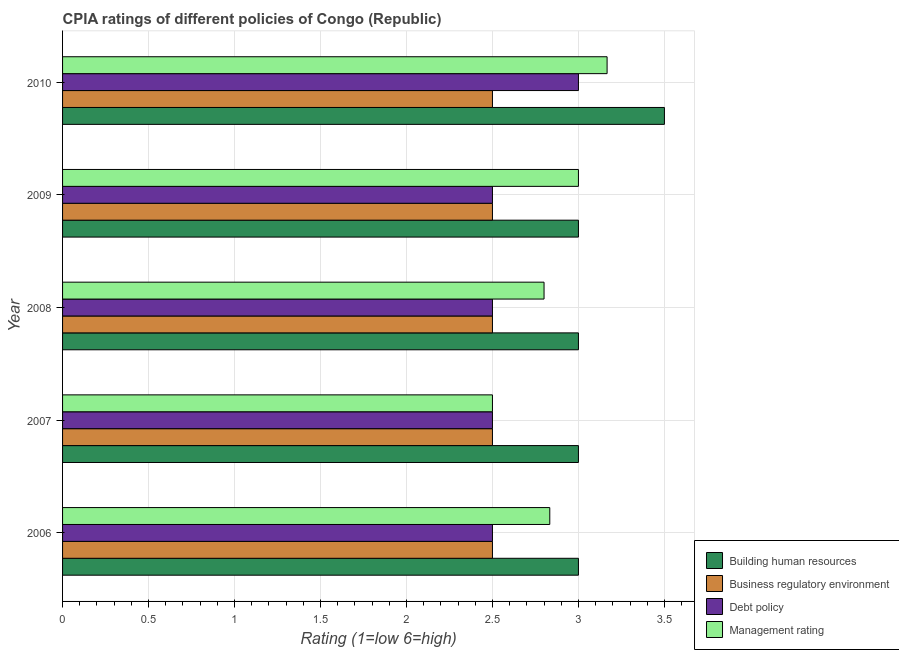How many different coloured bars are there?
Make the answer very short. 4. Are the number of bars per tick equal to the number of legend labels?
Offer a very short reply. Yes. How many bars are there on the 5th tick from the top?
Make the answer very short. 4. In how many cases, is the number of bars for a given year not equal to the number of legend labels?
Your answer should be very brief. 0. Across all years, what is the maximum cpia rating of business regulatory environment?
Offer a terse response. 2.5. In which year was the cpia rating of management maximum?
Ensure brevity in your answer.  2010. In which year was the cpia rating of business regulatory environment minimum?
Provide a short and direct response. 2006. What is the total cpia rating of business regulatory environment in the graph?
Your answer should be compact. 12.5. What is the average cpia rating of management per year?
Give a very brief answer. 2.86. What is the difference between the highest and the second highest cpia rating of management?
Your answer should be very brief. 0.17. What is the difference between the highest and the lowest cpia rating of management?
Offer a terse response. 0.67. In how many years, is the cpia rating of debt policy greater than the average cpia rating of debt policy taken over all years?
Provide a short and direct response. 1. Is the sum of the cpia rating of business regulatory environment in 2006 and 2008 greater than the maximum cpia rating of building human resources across all years?
Ensure brevity in your answer.  Yes. Is it the case that in every year, the sum of the cpia rating of management and cpia rating of building human resources is greater than the sum of cpia rating of debt policy and cpia rating of business regulatory environment?
Your response must be concise. No. What does the 2nd bar from the top in 2008 represents?
Offer a very short reply. Debt policy. What does the 4th bar from the bottom in 2009 represents?
Make the answer very short. Management rating. How many bars are there?
Give a very brief answer. 20. Are all the bars in the graph horizontal?
Your response must be concise. Yes. How many legend labels are there?
Offer a very short reply. 4. How are the legend labels stacked?
Your answer should be very brief. Vertical. What is the title of the graph?
Your answer should be very brief. CPIA ratings of different policies of Congo (Republic). Does "Fiscal policy" appear as one of the legend labels in the graph?
Provide a short and direct response. No. What is the label or title of the X-axis?
Give a very brief answer. Rating (1=low 6=high). What is the label or title of the Y-axis?
Your answer should be very brief. Year. What is the Rating (1=low 6=high) of Business regulatory environment in 2006?
Give a very brief answer. 2.5. What is the Rating (1=low 6=high) in Management rating in 2006?
Ensure brevity in your answer.  2.83. What is the Rating (1=low 6=high) of Business regulatory environment in 2008?
Offer a very short reply. 2.5. What is the Rating (1=low 6=high) in Debt policy in 2008?
Provide a short and direct response. 2.5. What is the Rating (1=low 6=high) of Management rating in 2008?
Offer a very short reply. 2.8. What is the Rating (1=low 6=high) in Business regulatory environment in 2009?
Make the answer very short. 2.5. What is the Rating (1=low 6=high) of Management rating in 2009?
Ensure brevity in your answer.  3. What is the Rating (1=low 6=high) of Management rating in 2010?
Ensure brevity in your answer.  3.17. Across all years, what is the maximum Rating (1=low 6=high) of Building human resources?
Make the answer very short. 3.5. Across all years, what is the maximum Rating (1=low 6=high) of Business regulatory environment?
Make the answer very short. 2.5. Across all years, what is the maximum Rating (1=low 6=high) in Management rating?
Make the answer very short. 3.17. Across all years, what is the minimum Rating (1=low 6=high) of Debt policy?
Provide a short and direct response. 2.5. Across all years, what is the minimum Rating (1=low 6=high) of Management rating?
Your response must be concise. 2.5. What is the total Rating (1=low 6=high) of Business regulatory environment in the graph?
Make the answer very short. 12.5. What is the total Rating (1=low 6=high) of Management rating in the graph?
Ensure brevity in your answer.  14.3. What is the difference between the Rating (1=low 6=high) in Building human resources in 2006 and that in 2007?
Provide a short and direct response. 0. What is the difference between the Rating (1=low 6=high) in Business regulatory environment in 2006 and that in 2007?
Give a very brief answer. 0. What is the difference between the Rating (1=low 6=high) in Building human resources in 2006 and that in 2008?
Ensure brevity in your answer.  0. What is the difference between the Rating (1=low 6=high) of Debt policy in 2006 and that in 2008?
Provide a succinct answer. 0. What is the difference between the Rating (1=low 6=high) of Business regulatory environment in 2006 and that in 2009?
Keep it short and to the point. 0. What is the difference between the Rating (1=low 6=high) of Management rating in 2006 and that in 2009?
Provide a short and direct response. -0.17. What is the difference between the Rating (1=low 6=high) of Building human resources in 2006 and that in 2010?
Your response must be concise. -0.5. What is the difference between the Rating (1=low 6=high) in Management rating in 2006 and that in 2010?
Keep it short and to the point. -0.33. What is the difference between the Rating (1=low 6=high) in Business regulatory environment in 2007 and that in 2008?
Give a very brief answer. 0. What is the difference between the Rating (1=low 6=high) of Debt policy in 2007 and that in 2008?
Keep it short and to the point. 0. What is the difference between the Rating (1=low 6=high) of Building human resources in 2007 and that in 2009?
Your answer should be compact. 0. What is the difference between the Rating (1=low 6=high) of Building human resources in 2007 and that in 2010?
Your response must be concise. -0.5. What is the difference between the Rating (1=low 6=high) of Debt policy in 2007 and that in 2010?
Provide a succinct answer. -0.5. What is the difference between the Rating (1=low 6=high) of Management rating in 2008 and that in 2009?
Provide a succinct answer. -0.2. What is the difference between the Rating (1=low 6=high) of Management rating in 2008 and that in 2010?
Your response must be concise. -0.37. What is the difference between the Rating (1=low 6=high) of Building human resources in 2009 and that in 2010?
Provide a short and direct response. -0.5. What is the difference between the Rating (1=low 6=high) of Business regulatory environment in 2009 and that in 2010?
Provide a short and direct response. 0. What is the difference between the Rating (1=low 6=high) of Management rating in 2009 and that in 2010?
Your response must be concise. -0.17. What is the difference between the Rating (1=low 6=high) of Building human resources in 2006 and the Rating (1=low 6=high) of Business regulatory environment in 2007?
Your answer should be very brief. 0.5. What is the difference between the Rating (1=low 6=high) in Debt policy in 2006 and the Rating (1=low 6=high) in Management rating in 2007?
Your answer should be compact. 0. What is the difference between the Rating (1=low 6=high) of Building human resources in 2006 and the Rating (1=low 6=high) of Business regulatory environment in 2008?
Your answer should be very brief. 0.5. What is the difference between the Rating (1=low 6=high) of Building human resources in 2006 and the Rating (1=low 6=high) of Debt policy in 2008?
Your answer should be compact. 0.5. What is the difference between the Rating (1=low 6=high) of Building human resources in 2006 and the Rating (1=low 6=high) of Debt policy in 2009?
Ensure brevity in your answer.  0.5. What is the difference between the Rating (1=low 6=high) of Building human resources in 2006 and the Rating (1=low 6=high) of Management rating in 2009?
Offer a very short reply. 0. What is the difference between the Rating (1=low 6=high) of Debt policy in 2006 and the Rating (1=low 6=high) of Management rating in 2009?
Your answer should be very brief. -0.5. What is the difference between the Rating (1=low 6=high) in Building human resources in 2006 and the Rating (1=low 6=high) in Business regulatory environment in 2010?
Give a very brief answer. 0.5. What is the difference between the Rating (1=low 6=high) of Building human resources in 2006 and the Rating (1=low 6=high) of Debt policy in 2010?
Provide a short and direct response. 0. What is the difference between the Rating (1=low 6=high) in Building human resources in 2006 and the Rating (1=low 6=high) in Management rating in 2010?
Provide a short and direct response. -0.17. What is the difference between the Rating (1=low 6=high) of Business regulatory environment in 2006 and the Rating (1=low 6=high) of Debt policy in 2010?
Make the answer very short. -0.5. What is the difference between the Rating (1=low 6=high) of Building human resources in 2007 and the Rating (1=low 6=high) of Business regulatory environment in 2008?
Ensure brevity in your answer.  0.5. What is the difference between the Rating (1=low 6=high) in Business regulatory environment in 2007 and the Rating (1=low 6=high) in Debt policy in 2008?
Offer a terse response. 0. What is the difference between the Rating (1=low 6=high) in Business regulatory environment in 2007 and the Rating (1=low 6=high) in Management rating in 2008?
Provide a succinct answer. -0.3. What is the difference between the Rating (1=low 6=high) of Debt policy in 2007 and the Rating (1=low 6=high) of Management rating in 2008?
Your answer should be very brief. -0.3. What is the difference between the Rating (1=low 6=high) of Building human resources in 2007 and the Rating (1=low 6=high) of Business regulatory environment in 2009?
Your response must be concise. 0.5. What is the difference between the Rating (1=low 6=high) in Building human resources in 2007 and the Rating (1=low 6=high) in Management rating in 2009?
Your answer should be very brief. 0. What is the difference between the Rating (1=low 6=high) in Business regulatory environment in 2007 and the Rating (1=low 6=high) in Debt policy in 2009?
Your answer should be compact. 0. What is the difference between the Rating (1=low 6=high) of Business regulatory environment in 2007 and the Rating (1=low 6=high) of Management rating in 2009?
Provide a short and direct response. -0.5. What is the difference between the Rating (1=low 6=high) in Building human resources in 2007 and the Rating (1=low 6=high) in Business regulatory environment in 2010?
Provide a succinct answer. 0.5. What is the difference between the Rating (1=low 6=high) in Building human resources in 2007 and the Rating (1=low 6=high) in Management rating in 2010?
Keep it short and to the point. -0.17. What is the difference between the Rating (1=low 6=high) of Business regulatory environment in 2007 and the Rating (1=low 6=high) of Debt policy in 2010?
Ensure brevity in your answer.  -0.5. What is the difference between the Rating (1=low 6=high) of Building human resources in 2008 and the Rating (1=low 6=high) of Business regulatory environment in 2009?
Keep it short and to the point. 0.5. What is the difference between the Rating (1=low 6=high) of Building human resources in 2008 and the Rating (1=low 6=high) of Management rating in 2009?
Offer a very short reply. 0. What is the difference between the Rating (1=low 6=high) of Business regulatory environment in 2008 and the Rating (1=low 6=high) of Management rating in 2009?
Your response must be concise. -0.5. What is the difference between the Rating (1=low 6=high) of Debt policy in 2008 and the Rating (1=low 6=high) of Management rating in 2009?
Offer a terse response. -0.5. What is the difference between the Rating (1=low 6=high) of Building human resources in 2008 and the Rating (1=low 6=high) of Business regulatory environment in 2010?
Provide a succinct answer. 0.5. What is the difference between the Rating (1=low 6=high) in Business regulatory environment in 2008 and the Rating (1=low 6=high) in Management rating in 2010?
Your answer should be compact. -0.67. What is the difference between the Rating (1=low 6=high) of Debt policy in 2008 and the Rating (1=low 6=high) of Management rating in 2010?
Offer a very short reply. -0.67. What is the difference between the Rating (1=low 6=high) in Business regulatory environment in 2009 and the Rating (1=low 6=high) in Debt policy in 2010?
Ensure brevity in your answer.  -0.5. What is the average Rating (1=low 6=high) of Debt policy per year?
Provide a short and direct response. 2.6. What is the average Rating (1=low 6=high) of Management rating per year?
Give a very brief answer. 2.86. In the year 2006, what is the difference between the Rating (1=low 6=high) of Building human resources and Rating (1=low 6=high) of Business regulatory environment?
Your answer should be compact. 0.5. In the year 2006, what is the difference between the Rating (1=low 6=high) of Building human resources and Rating (1=low 6=high) of Debt policy?
Keep it short and to the point. 0.5. In the year 2006, what is the difference between the Rating (1=low 6=high) in Debt policy and Rating (1=low 6=high) in Management rating?
Make the answer very short. -0.33. In the year 2007, what is the difference between the Rating (1=low 6=high) of Building human resources and Rating (1=low 6=high) of Business regulatory environment?
Your answer should be compact. 0.5. In the year 2007, what is the difference between the Rating (1=low 6=high) of Building human resources and Rating (1=low 6=high) of Debt policy?
Provide a short and direct response. 0.5. In the year 2007, what is the difference between the Rating (1=low 6=high) of Building human resources and Rating (1=low 6=high) of Management rating?
Keep it short and to the point. 0.5. In the year 2007, what is the difference between the Rating (1=low 6=high) in Business regulatory environment and Rating (1=low 6=high) in Debt policy?
Keep it short and to the point. 0. In the year 2007, what is the difference between the Rating (1=low 6=high) in Business regulatory environment and Rating (1=low 6=high) in Management rating?
Give a very brief answer. 0. In the year 2008, what is the difference between the Rating (1=low 6=high) in Building human resources and Rating (1=low 6=high) in Management rating?
Offer a terse response. 0.2. In the year 2008, what is the difference between the Rating (1=low 6=high) of Business regulatory environment and Rating (1=low 6=high) of Debt policy?
Offer a very short reply. 0. In the year 2009, what is the difference between the Rating (1=low 6=high) of Building human resources and Rating (1=low 6=high) of Debt policy?
Provide a succinct answer. 0.5. In the year 2009, what is the difference between the Rating (1=low 6=high) of Building human resources and Rating (1=low 6=high) of Management rating?
Give a very brief answer. 0. In the year 2009, what is the difference between the Rating (1=low 6=high) of Business regulatory environment and Rating (1=low 6=high) of Debt policy?
Offer a very short reply. 0. In the year 2009, what is the difference between the Rating (1=low 6=high) of Debt policy and Rating (1=low 6=high) of Management rating?
Offer a very short reply. -0.5. In the year 2010, what is the difference between the Rating (1=low 6=high) of Building human resources and Rating (1=low 6=high) of Business regulatory environment?
Give a very brief answer. 1. In the year 2010, what is the difference between the Rating (1=low 6=high) in Building human resources and Rating (1=low 6=high) in Management rating?
Offer a terse response. 0.33. In the year 2010, what is the difference between the Rating (1=low 6=high) of Business regulatory environment and Rating (1=low 6=high) of Management rating?
Offer a very short reply. -0.67. In the year 2010, what is the difference between the Rating (1=low 6=high) in Debt policy and Rating (1=low 6=high) in Management rating?
Your response must be concise. -0.17. What is the ratio of the Rating (1=low 6=high) in Business regulatory environment in 2006 to that in 2007?
Ensure brevity in your answer.  1. What is the ratio of the Rating (1=low 6=high) of Debt policy in 2006 to that in 2007?
Provide a short and direct response. 1. What is the ratio of the Rating (1=low 6=high) in Management rating in 2006 to that in 2007?
Provide a short and direct response. 1.13. What is the ratio of the Rating (1=low 6=high) of Building human resources in 2006 to that in 2008?
Offer a terse response. 1. What is the ratio of the Rating (1=low 6=high) in Business regulatory environment in 2006 to that in 2008?
Keep it short and to the point. 1. What is the ratio of the Rating (1=low 6=high) in Management rating in 2006 to that in 2008?
Keep it short and to the point. 1.01. What is the ratio of the Rating (1=low 6=high) in Management rating in 2006 to that in 2010?
Make the answer very short. 0.89. What is the ratio of the Rating (1=low 6=high) of Building human resources in 2007 to that in 2008?
Your response must be concise. 1. What is the ratio of the Rating (1=low 6=high) of Business regulatory environment in 2007 to that in 2008?
Offer a very short reply. 1. What is the ratio of the Rating (1=low 6=high) of Management rating in 2007 to that in 2008?
Offer a very short reply. 0.89. What is the ratio of the Rating (1=low 6=high) in Business regulatory environment in 2007 to that in 2009?
Make the answer very short. 1. What is the ratio of the Rating (1=low 6=high) of Debt policy in 2007 to that in 2009?
Give a very brief answer. 1. What is the ratio of the Rating (1=low 6=high) of Building human resources in 2007 to that in 2010?
Keep it short and to the point. 0.86. What is the ratio of the Rating (1=low 6=high) of Management rating in 2007 to that in 2010?
Provide a succinct answer. 0.79. What is the ratio of the Rating (1=low 6=high) of Building human resources in 2008 to that in 2009?
Give a very brief answer. 1. What is the ratio of the Rating (1=low 6=high) of Business regulatory environment in 2008 to that in 2009?
Offer a terse response. 1. What is the ratio of the Rating (1=low 6=high) in Debt policy in 2008 to that in 2009?
Provide a short and direct response. 1. What is the ratio of the Rating (1=low 6=high) in Management rating in 2008 to that in 2009?
Give a very brief answer. 0.93. What is the ratio of the Rating (1=low 6=high) of Building human resources in 2008 to that in 2010?
Give a very brief answer. 0.86. What is the ratio of the Rating (1=low 6=high) of Business regulatory environment in 2008 to that in 2010?
Offer a very short reply. 1. What is the ratio of the Rating (1=low 6=high) in Debt policy in 2008 to that in 2010?
Provide a short and direct response. 0.83. What is the ratio of the Rating (1=low 6=high) of Management rating in 2008 to that in 2010?
Provide a succinct answer. 0.88. What is the difference between the highest and the second highest Rating (1=low 6=high) in Building human resources?
Provide a succinct answer. 0.5. What is the difference between the highest and the second highest Rating (1=low 6=high) of Business regulatory environment?
Give a very brief answer. 0. What is the difference between the highest and the second highest Rating (1=low 6=high) in Debt policy?
Provide a short and direct response. 0.5. What is the difference between the highest and the second highest Rating (1=low 6=high) of Management rating?
Make the answer very short. 0.17. What is the difference between the highest and the lowest Rating (1=low 6=high) in Building human resources?
Offer a terse response. 0.5. 